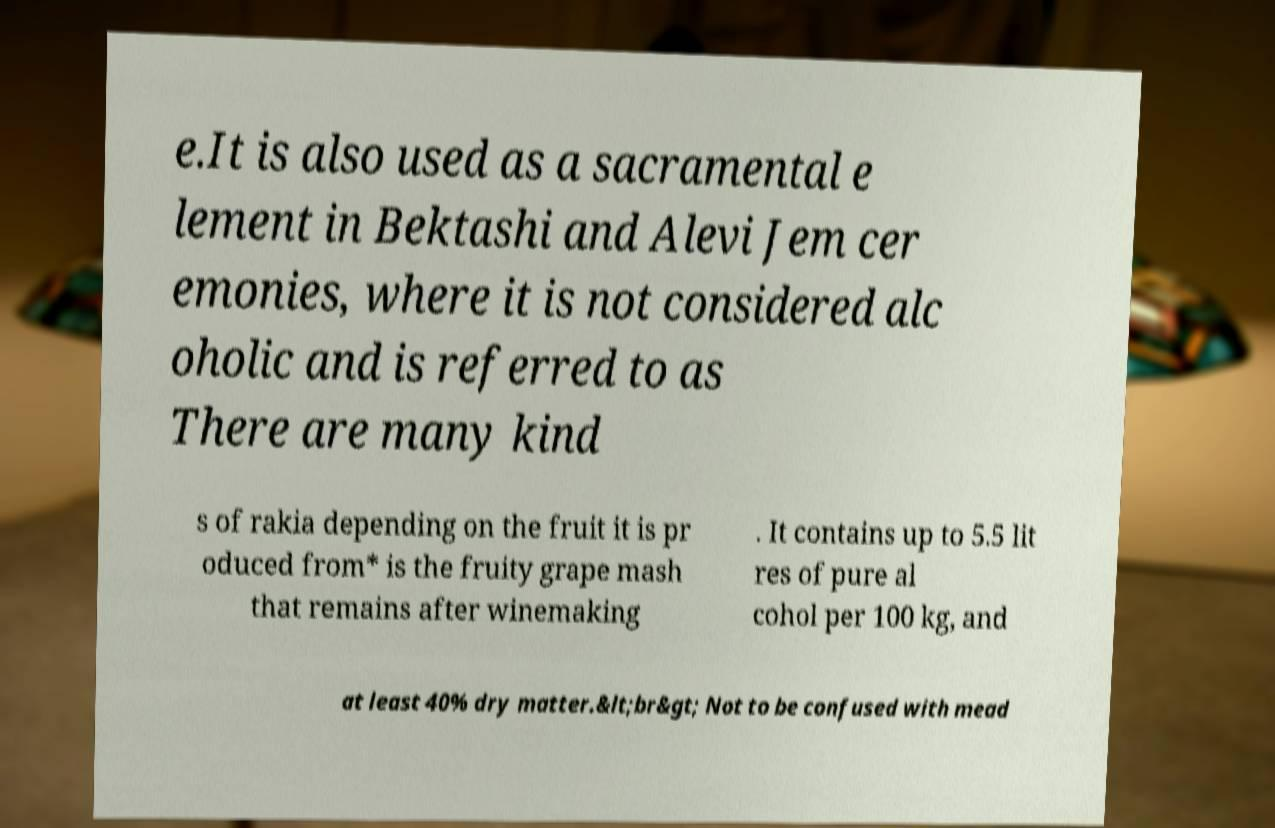For documentation purposes, I need the text within this image transcribed. Could you provide that? e.It is also used as a sacramental e lement in Bektashi and Alevi Jem cer emonies, where it is not considered alc oholic and is referred to as There are many kind s of rakia depending on the fruit it is pr oduced from* is the fruity grape mash that remains after winemaking . It contains up to 5.5 lit res of pure al cohol per 100 kg, and at least 40% dry matter.&lt;br&gt; Not to be confused with mead 